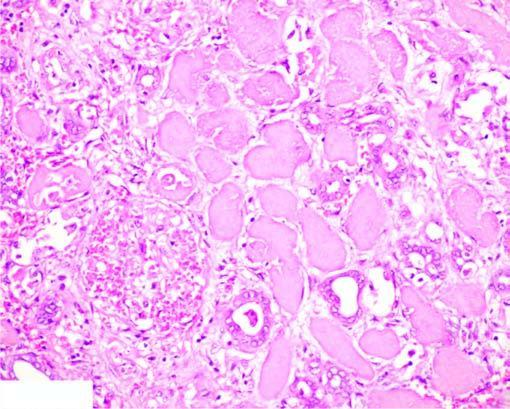what show granular debris?
Answer the question using a single word or phrase. The nuclei debris 